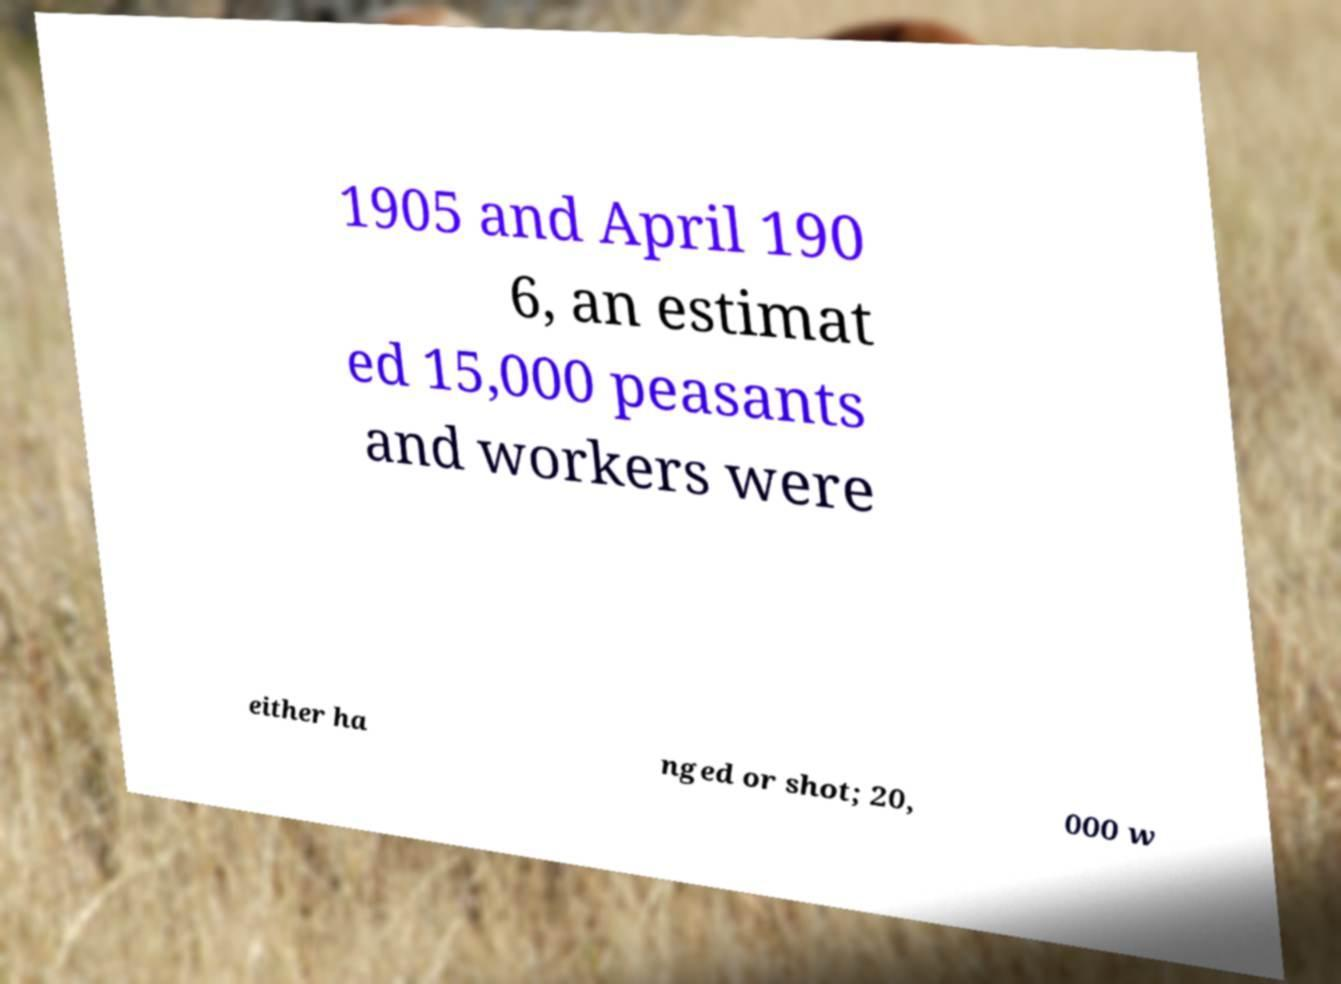Please identify and transcribe the text found in this image. 1905 and April 190 6, an estimat ed 15,000 peasants and workers were either ha nged or shot; 20, 000 w 